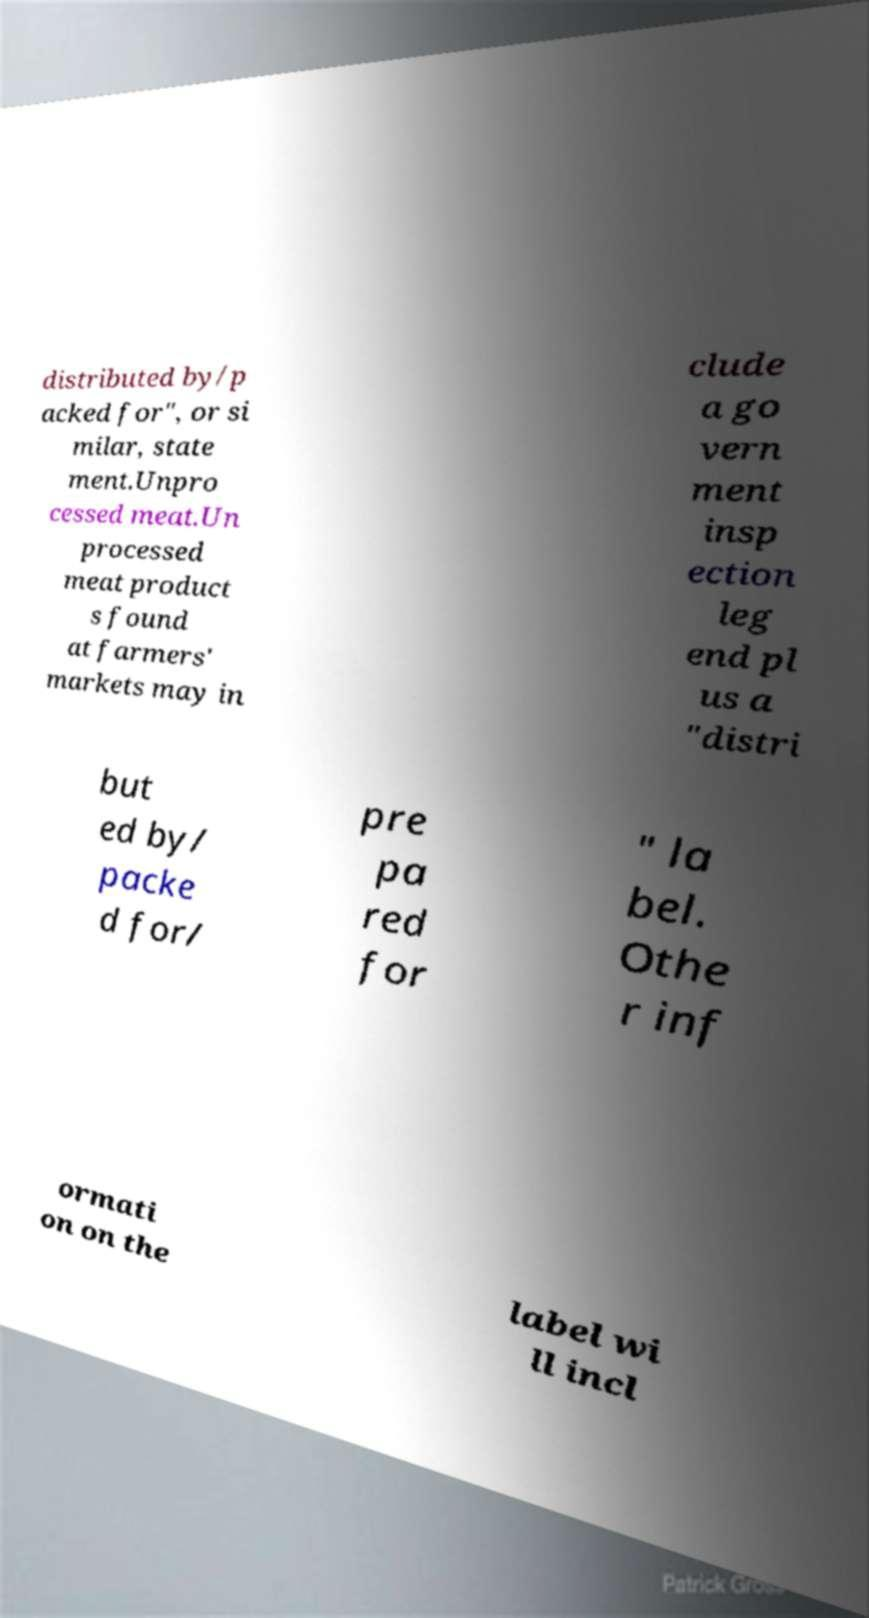There's text embedded in this image that I need extracted. Can you transcribe it verbatim? distributed by/p acked for", or si milar, state ment.Unpro cessed meat.Un processed meat product s found at farmers' markets may in clude a go vern ment insp ection leg end pl us a "distri but ed by/ packe d for/ pre pa red for " la bel. Othe r inf ormati on on the label wi ll incl 